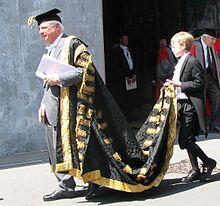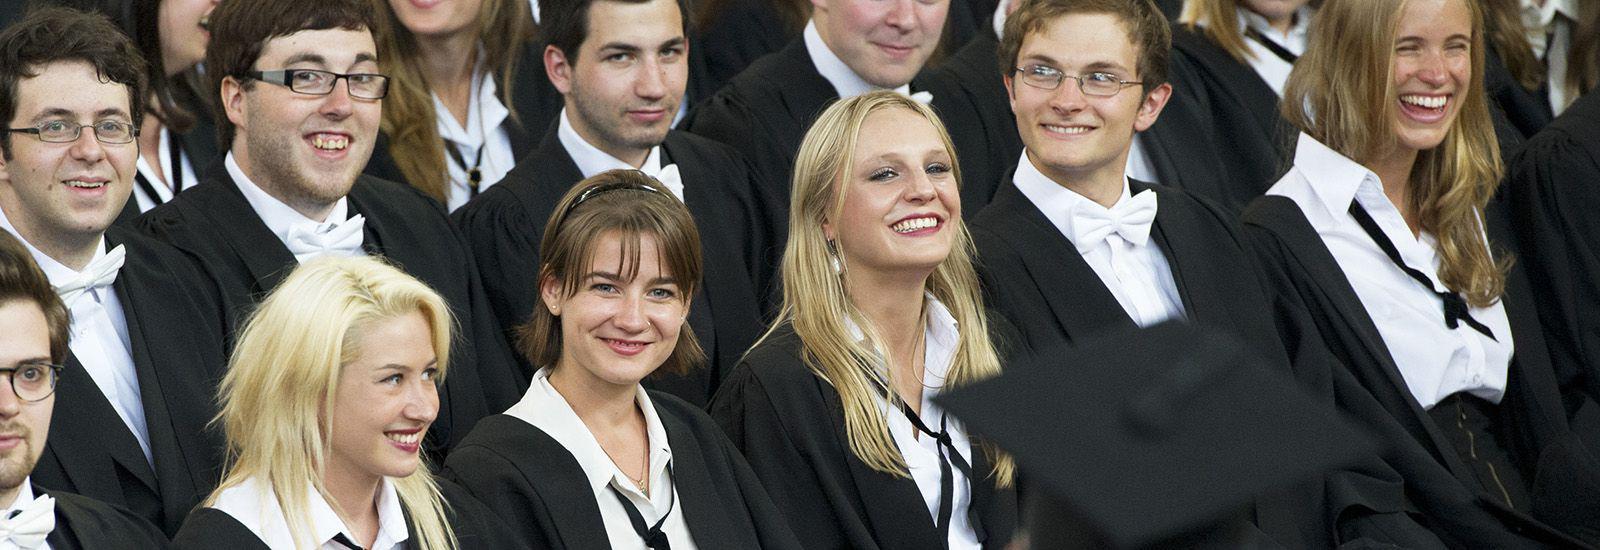The first image is the image on the left, the second image is the image on the right. Evaluate the accuracy of this statement regarding the images: "The right image contains exactly four humans wearing graduation uniforms.". Is it true? Answer yes or no. No. The first image is the image on the left, the second image is the image on the right. Examine the images to the left and right. Is the description "There are at least eight people in total." accurate? Answer yes or no. Yes. 